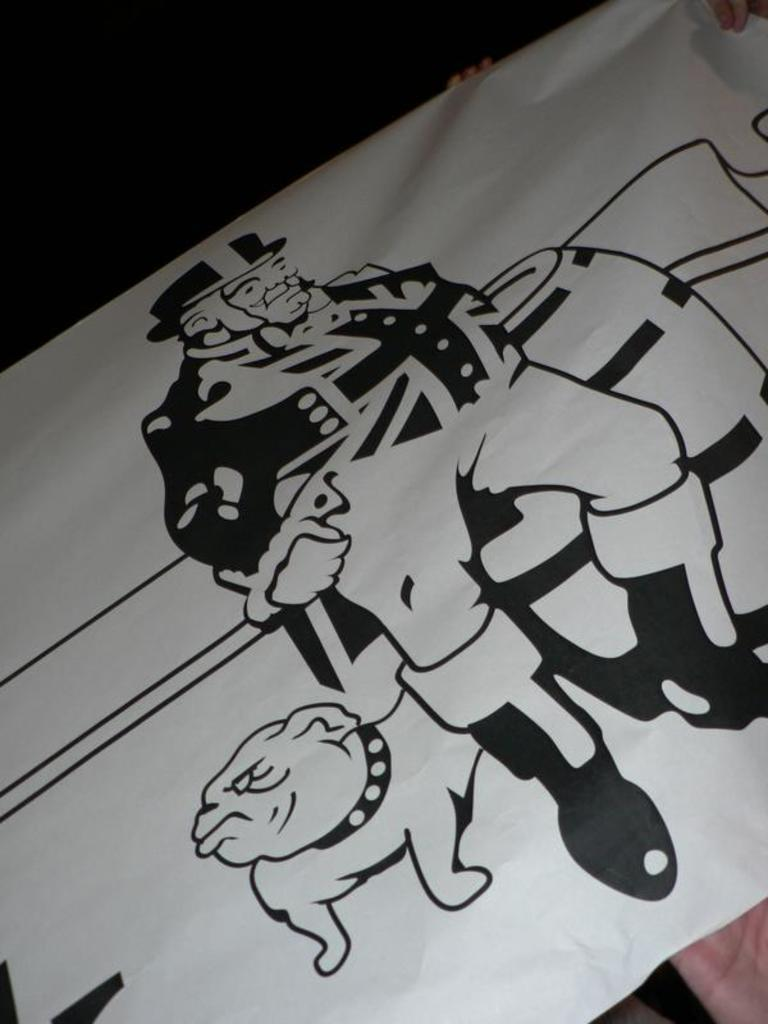What is present in the image that contains a drawing? There is a banner in the image that contains a drawing. What two subjects are depicted in the drawing on the banner? The drawing on the banner contains a drawing of a person and a dog. What type of wine is being served at the playground depicted in the image? There is no playground or wine present in the image; it only features a banner with drawings of a person and a dog. 